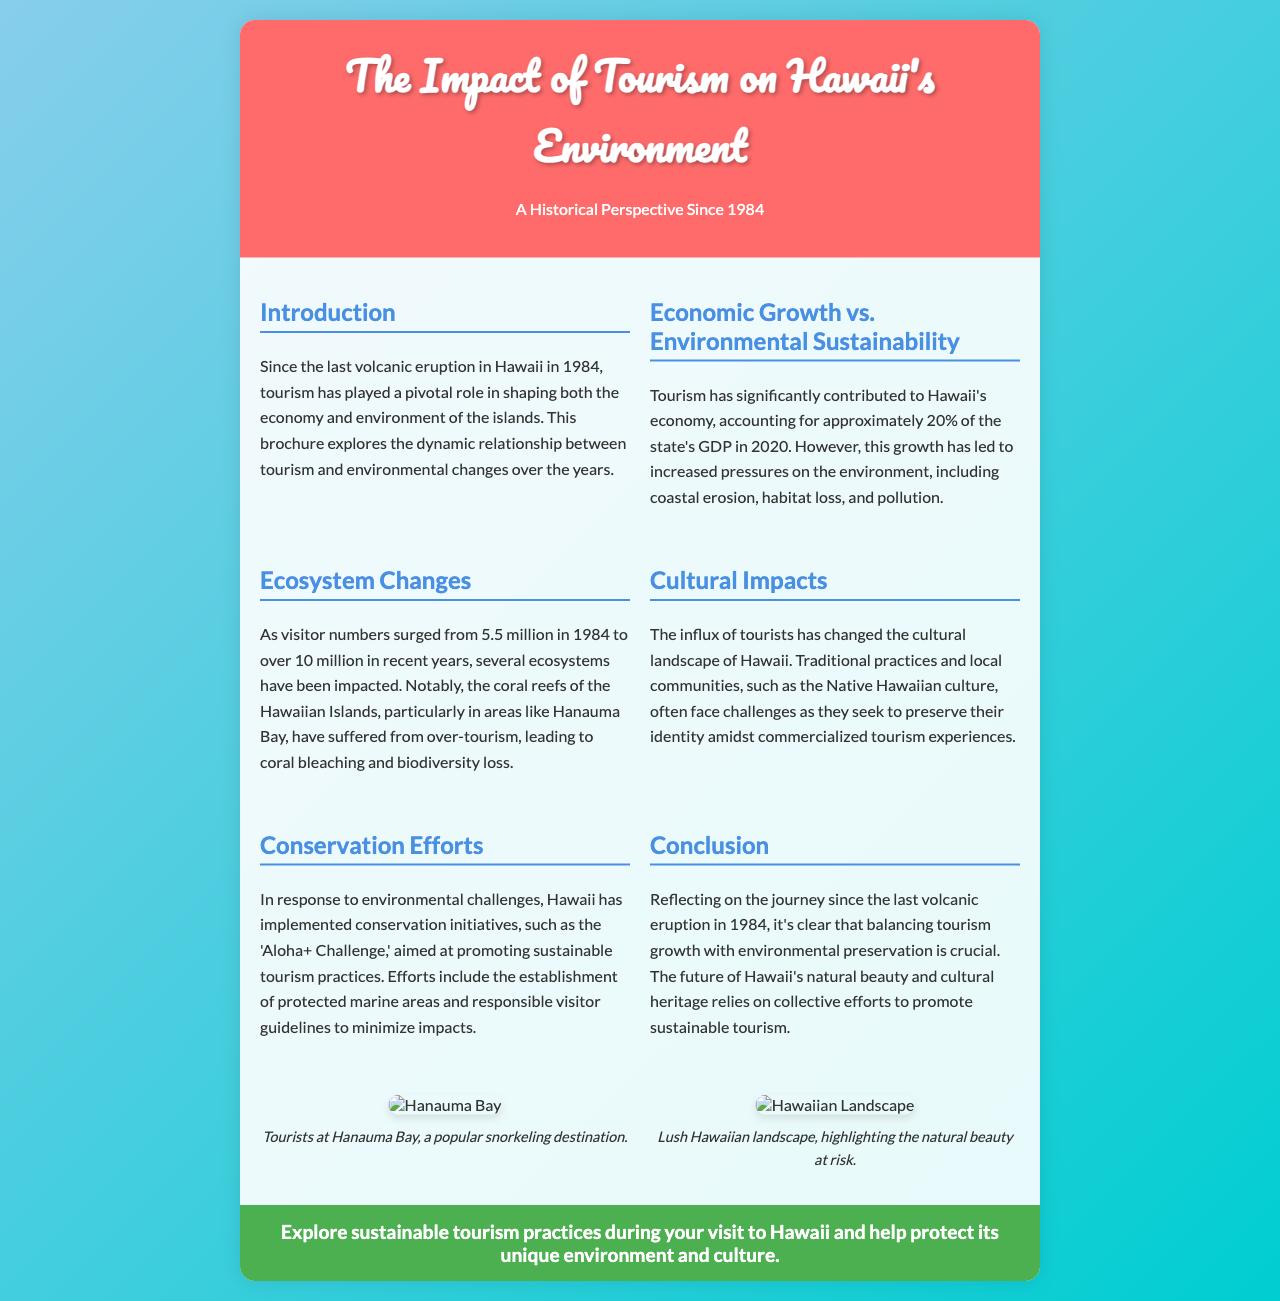What percentage of Hawaii's GDP did tourism account for in 2020? The document states that tourism accounted for approximately 20% of Hawaii's GDP in 2020.
Answer: 20% How many tourists visited Hawaii in 1984? The brochure mentions that visitor numbers were 5.5 million in 1984.
Answer: 5.5 million What is the Aloha+ Challenge? The document describes the 'Aloha+ Challenge' as an initiative aimed at promoting sustainable tourism practices.
Answer: Sustainable tourism practices What is one major environmental issue caused by tourism in Hawaii? The brochure highlights coastal erosion, habitat loss, and pollution as major issues caused by tourism in Hawaii.
Answer: Coastal erosion What has happened to coral reefs in Hawaii due to tourism? The document states that the coral reefs, particularly in areas like Hanauma Bay, have suffered from over-tourism, leading to coral bleaching.
Answer: Coral bleaching What is the purpose of the conservation initiatives mentioned in the document? The initiatives aim to promote sustainable tourism practices and minimize environmental impacts.
Answer: Promote sustainable tourism How has tourism impacted Native Hawaiian culture? The brochure explains that traditional practices and local communities face challenges in preserving their identity due to commercialized tourism.
Answer: Preserving their identity What two locations are featured in the images of the brochure? The images feature Hanauma Bay and a lush Hawaiian landscape, emphasizing natural beauty.
Answer: Hanauma Bay and Hawaiian landscape 